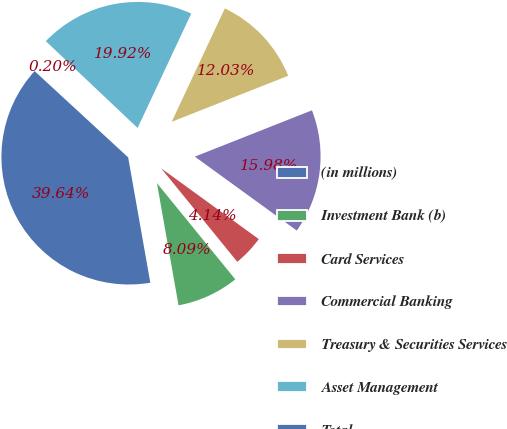Convert chart. <chart><loc_0><loc_0><loc_500><loc_500><pie_chart><fcel>(in millions)<fcel>Investment Bank (b)<fcel>Card Services<fcel>Commercial Banking<fcel>Treasury & Securities Services<fcel>Asset Management<fcel>Total<nl><fcel>39.64%<fcel>8.09%<fcel>4.14%<fcel>15.98%<fcel>12.03%<fcel>19.92%<fcel>0.2%<nl></chart> 